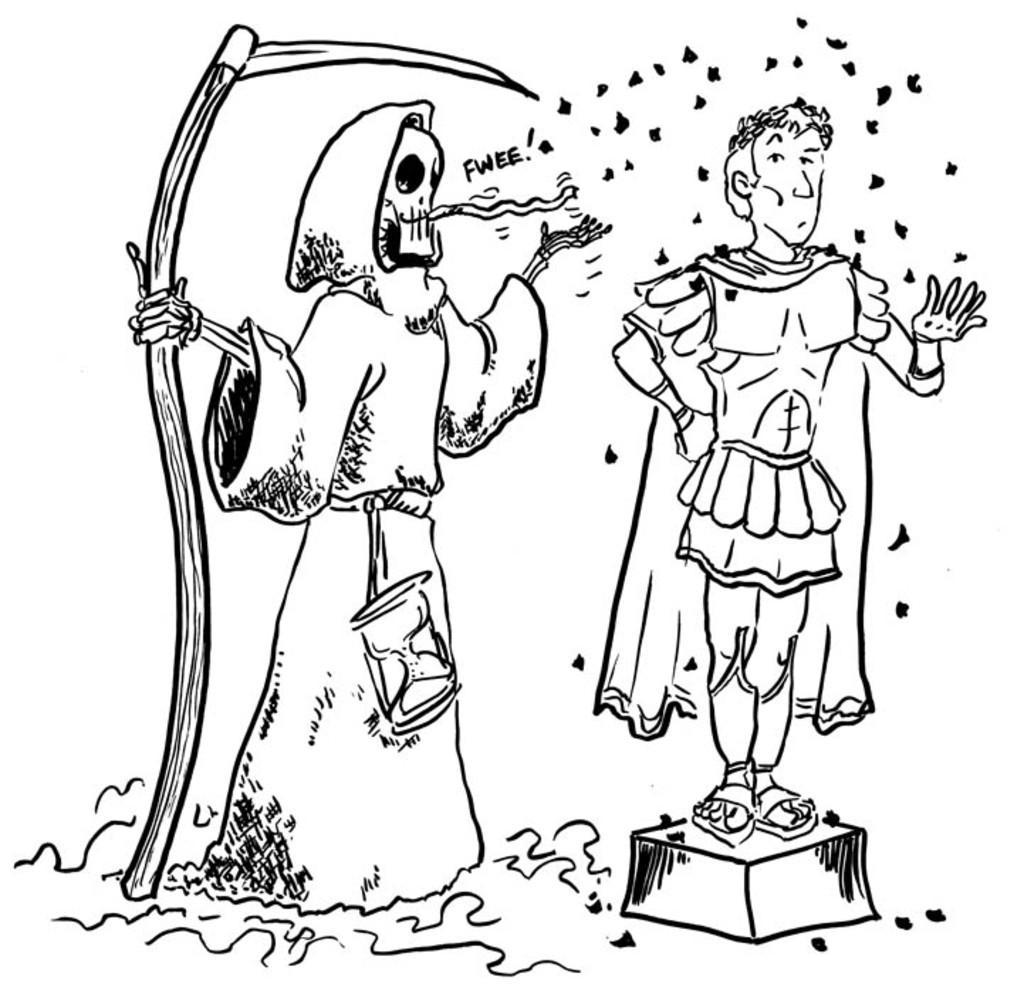Could you give a brief overview of what you see in this image? This is a drawing in this image there are two persons who are standing, and at the bottom there is grass. 